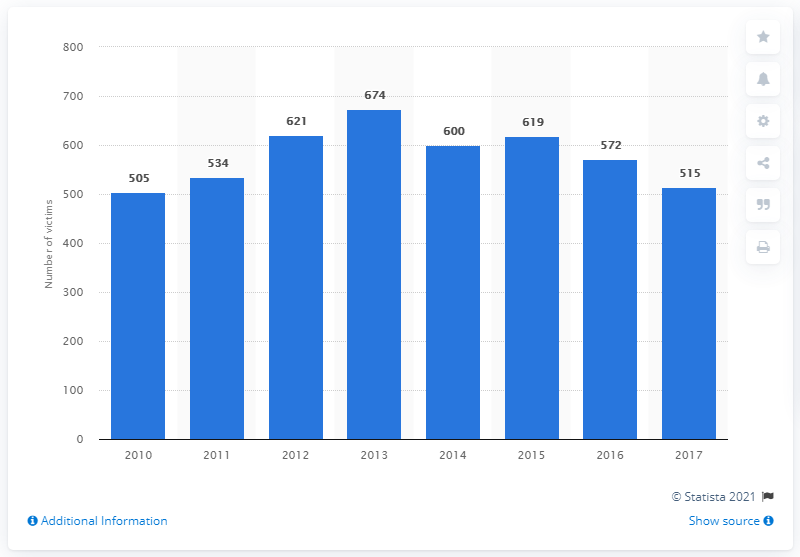Identify some key points in this picture. According to official statistics, 515 people were murdered in Cuba in 2017. There were 572 reported intentional homicides in Cuba in 2016. 